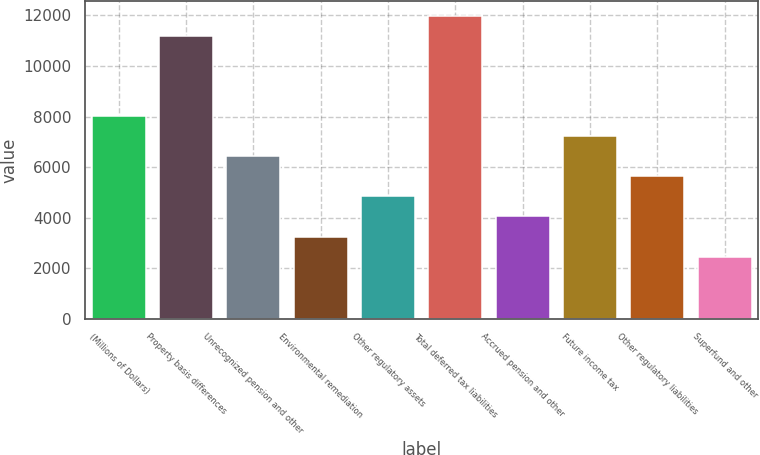<chart> <loc_0><loc_0><loc_500><loc_500><bar_chart><fcel>(Millions of Dollars)<fcel>Property basis differences<fcel>Unrecognized pension and other<fcel>Environmental remediation<fcel>Other regulatory assets<fcel>Total deferred tax liabilities<fcel>Accrued pension and other<fcel>Future income tax<fcel>Other regulatory liabilities<fcel>Superfund and other<nl><fcel>8014<fcel>11185.2<fcel>6428.4<fcel>3257.2<fcel>4842.8<fcel>11978<fcel>4050<fcel>7221.2<fcel>5635.6<fcel>2464.4<nl></chart> 